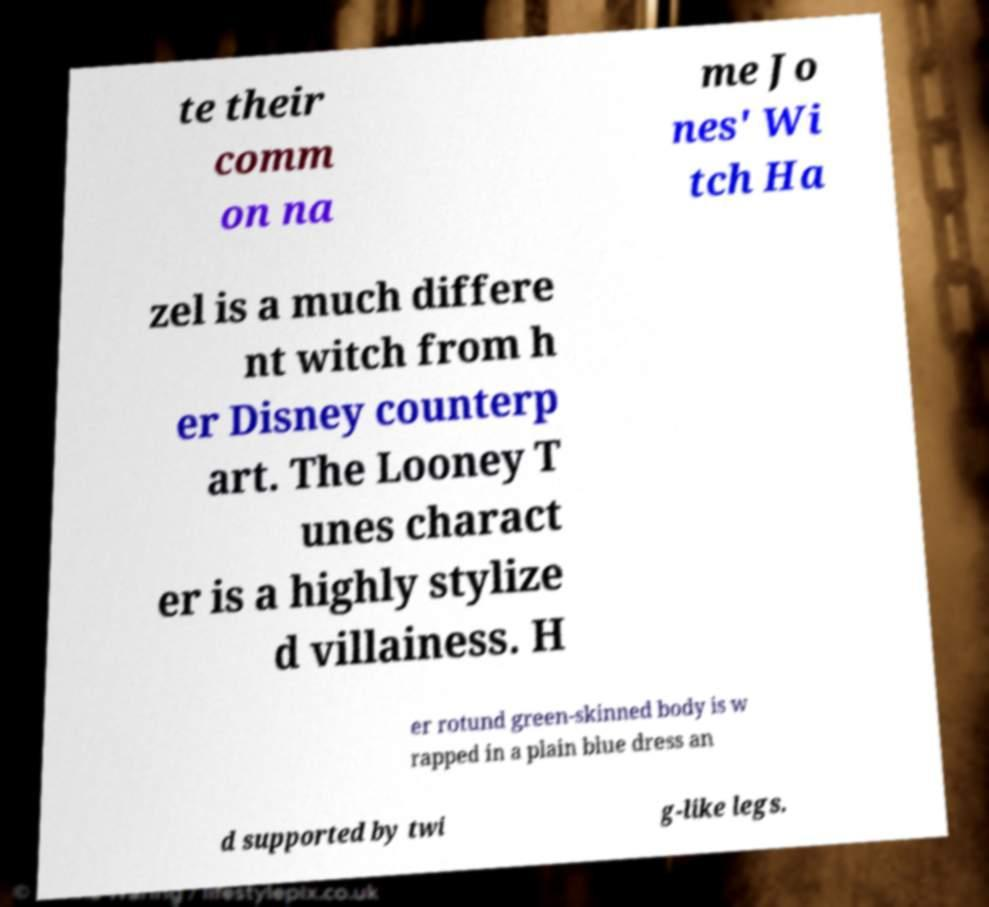Please identify and transcribe the text found in this image. te their comm on na me Jo nes' Wi tch Ha zel is a much differe nt witch from h er Disney counterp art. The Looney T unes charact er is a highly stylize d villainess. H er rotund green-skinned body is w rapped in a plain blue dress an d supported by twi g-like legs. 